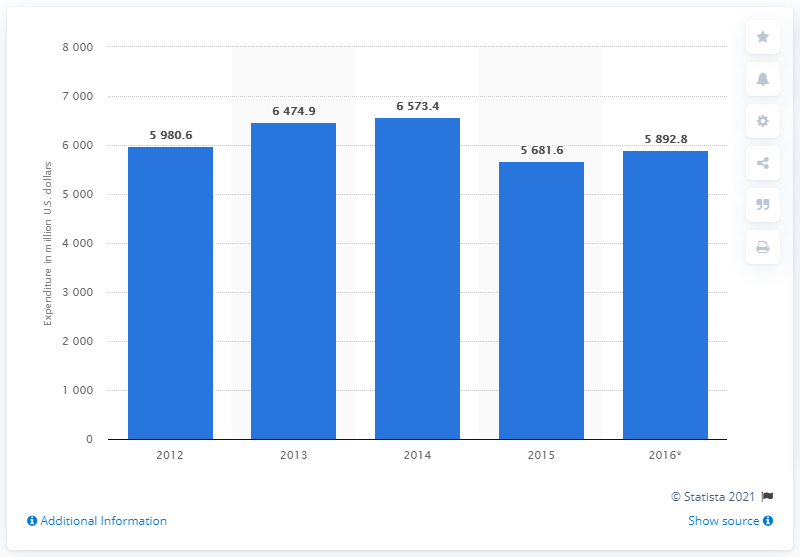Outline some significant characteristics in this image. In 2016, the estimated expenditure on food is projected to be 5,892.8 million. 